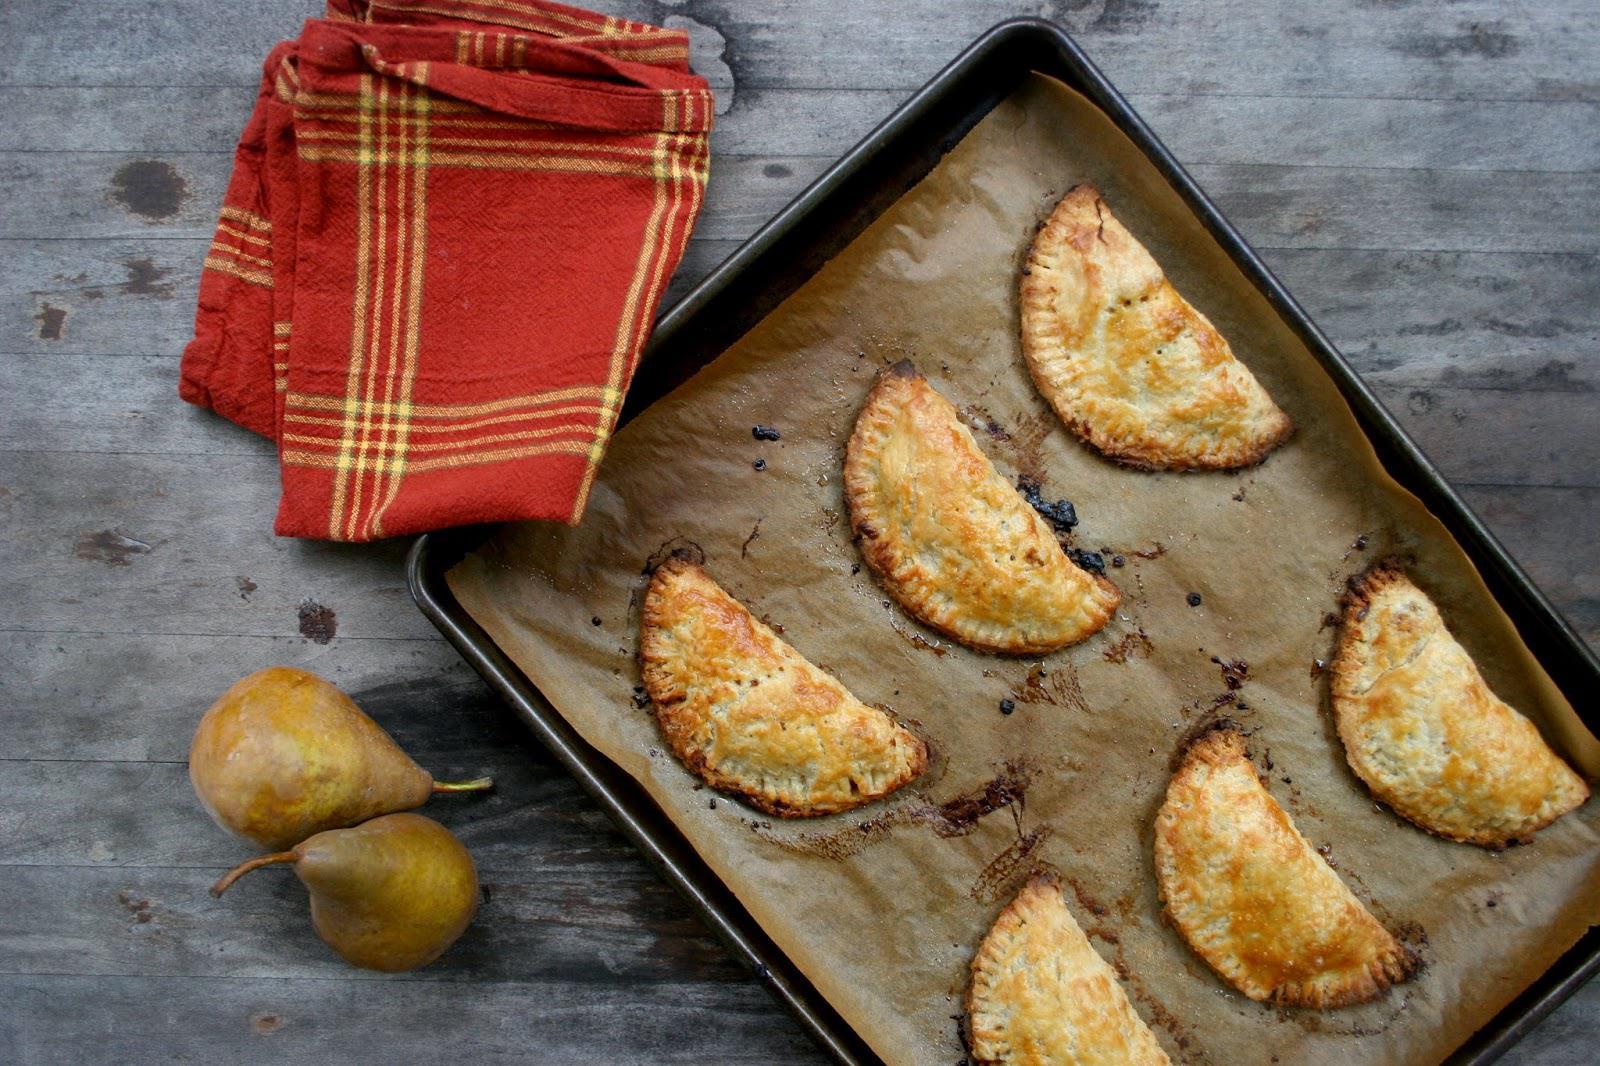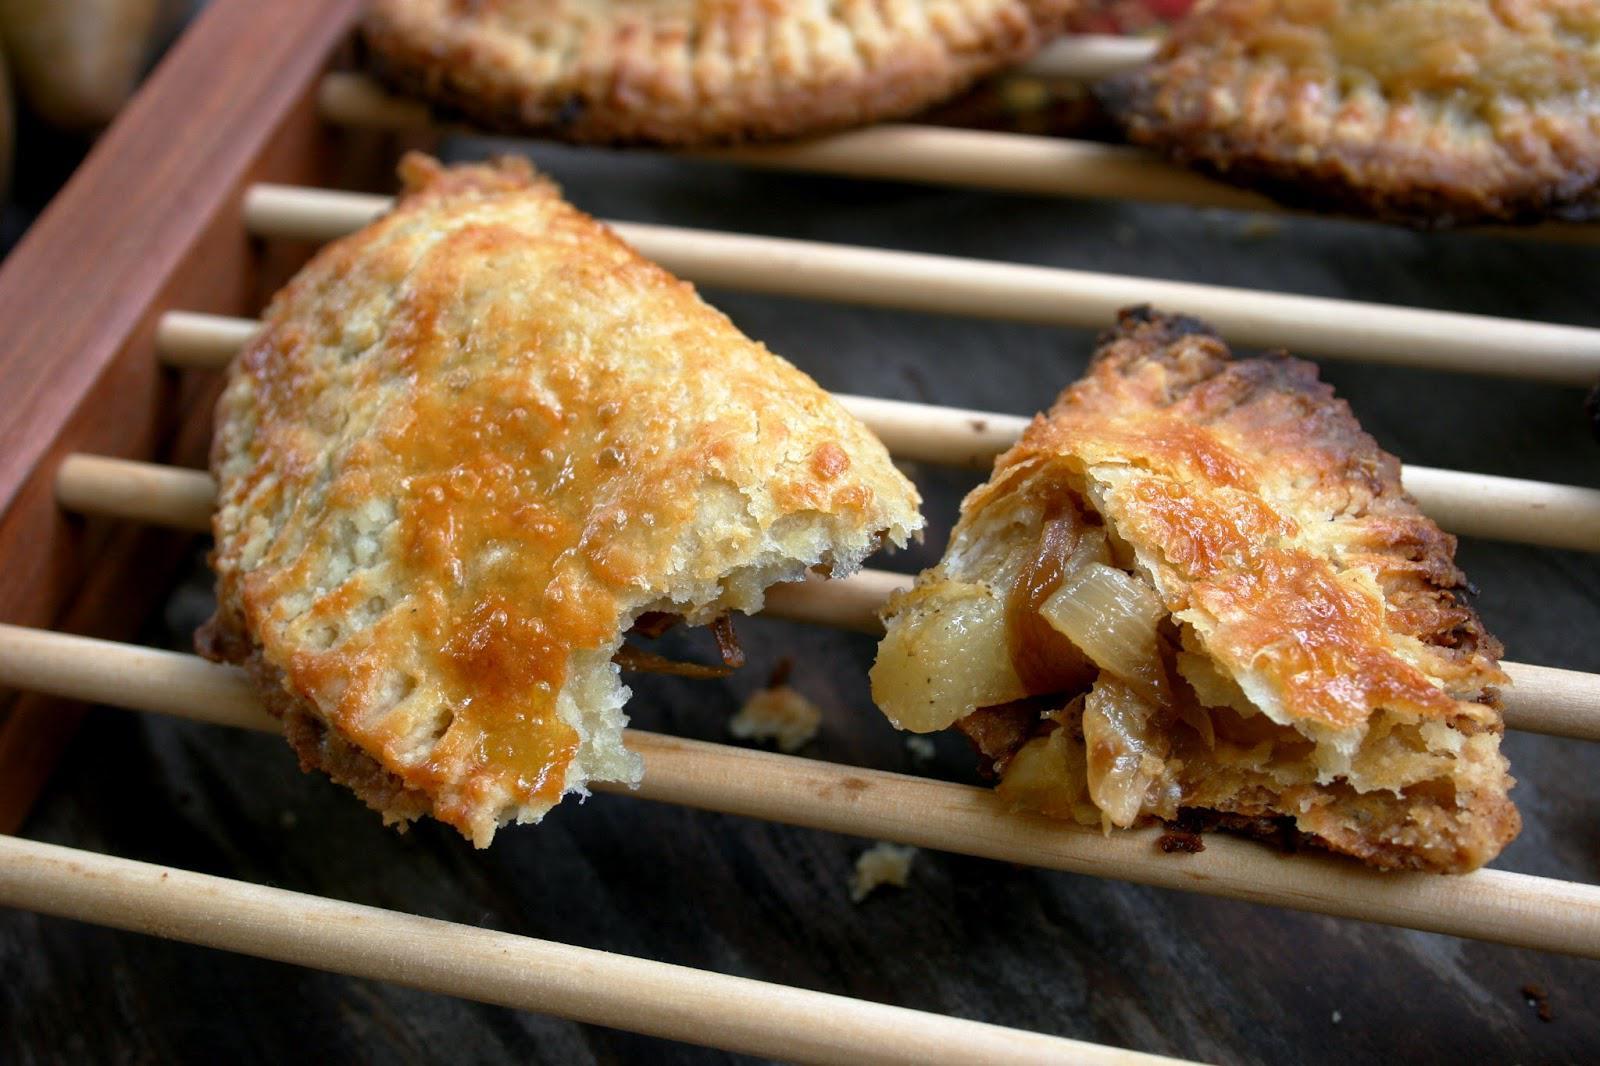The first image is the image on the left, the second image is the image on the right. Considering the images on both sides, is "The left image features half-circle shapes on a rectangle with edges, and the right image features something shaped like a slice of pie." valid? Answer yes or no. Yes. The first image is the image on the left, the second image is the image on the right. Considering the images on both sides, is "In the image on the left, the dough products are arranged neatly on a baking sheet." valid? Answer yes or no. Yes. 